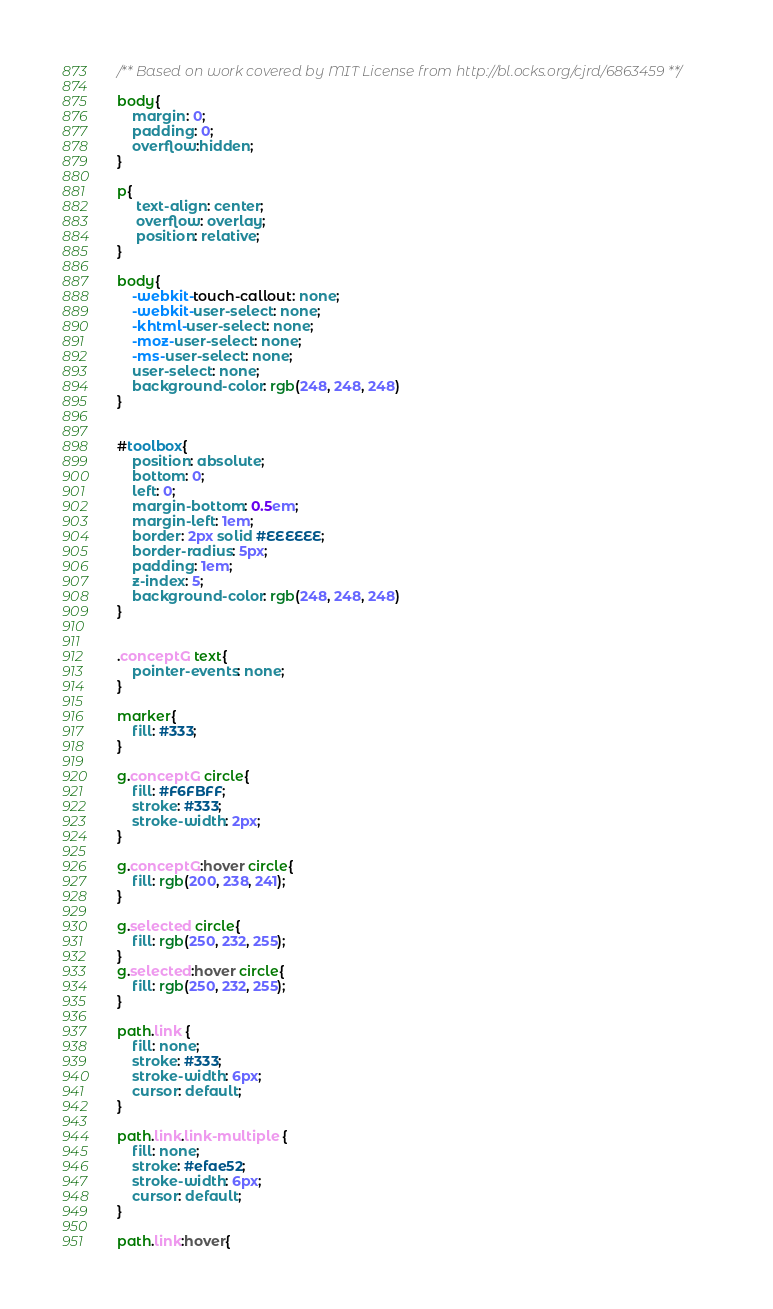Convert code to text. <code><loc_0><loc_0><loc_500><loc_500><_CSS_>/** Based on work covered by MIT License from http://bl.ocks.org/cjrd/6863459 **/

body{
    margin: 0;
    padding: 0;
    overflow:hidden;
}

p{
     text-align: center;
     overflow: overlay;
     position: relative;
}

body{
    -webkit-touch-callout: none;
    -webkit-user-select: none;
    -khtml-user-select: none;
    -moz-user-select: none;
    -ms-user-select: none;
    user-select: none;
    background-color: rgb(248, 248, 248)
}


#toolbox{
    position: absolute;
    bottom: 0;
    left: 0;
    margin-bottom: 0.5em;
    margin-left: 1em;
    border: 2px solid #EEEEEE;
    border-radius: 5px;
    padding: 1em;
    z-index: 5;
    background-color: rgb(248, 248, 248)
}


.conceptG text{
    pointer-events: none;
}

marker{
    fill: #333;
}

g.conceptG circle{
    fill: #F6FBFF;
    stroke: #333;
    stroke-width: 2px;
}

g.conceptG:hover circle{
    fill: rgb(200, 238, 241);
}

g.selected circle{
    fill: rgb(250, 232, 255);
}
g.selected:hover circle{
    fill: rgb(250, 232, 255);
}

path.link {
    fill: none;
    stroke: #333;
    stroke-width: 6px;
    cursor: default;
}

path.link.link-multiple {
    fill: none;
    stroke: #efae52;
    stroke-width: 6px;
    cursor: default;
}

path.link:hover{</code> 